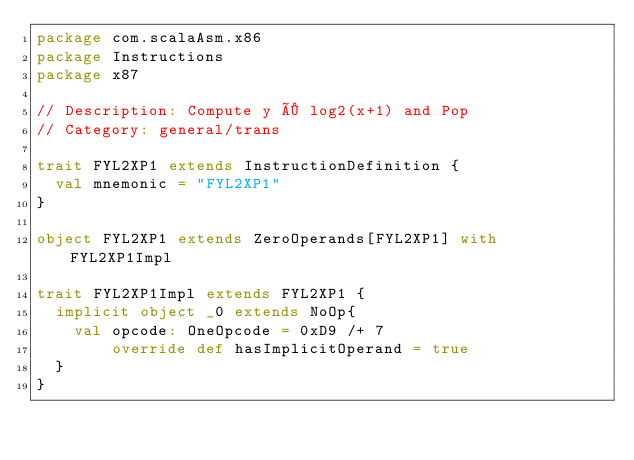Convert code to text. <code><loc_0><loc_0><loc_500><loc_500><_Scala_>package com.scalaAsm.x86
package Instructions
package x87

// Description: Compute y × log2(x+1) and Pop
// Category: general/trans

trait FYL2XP1 extends InstructionDefinition {
  val mnemonic = "FYL2XP1"
}

object FYL2XP1 extends ZeroOperands[FYL2XP1] with FYL2XP1Impl

trait FYL2XP1Impl extends FYL2XP1 {
  implicit object _0 extends NoOp{
    val opcode: OneOpcode = 0xD9 /+ 7
        override def hasImplicitOperand = true
  }
}
</code> 